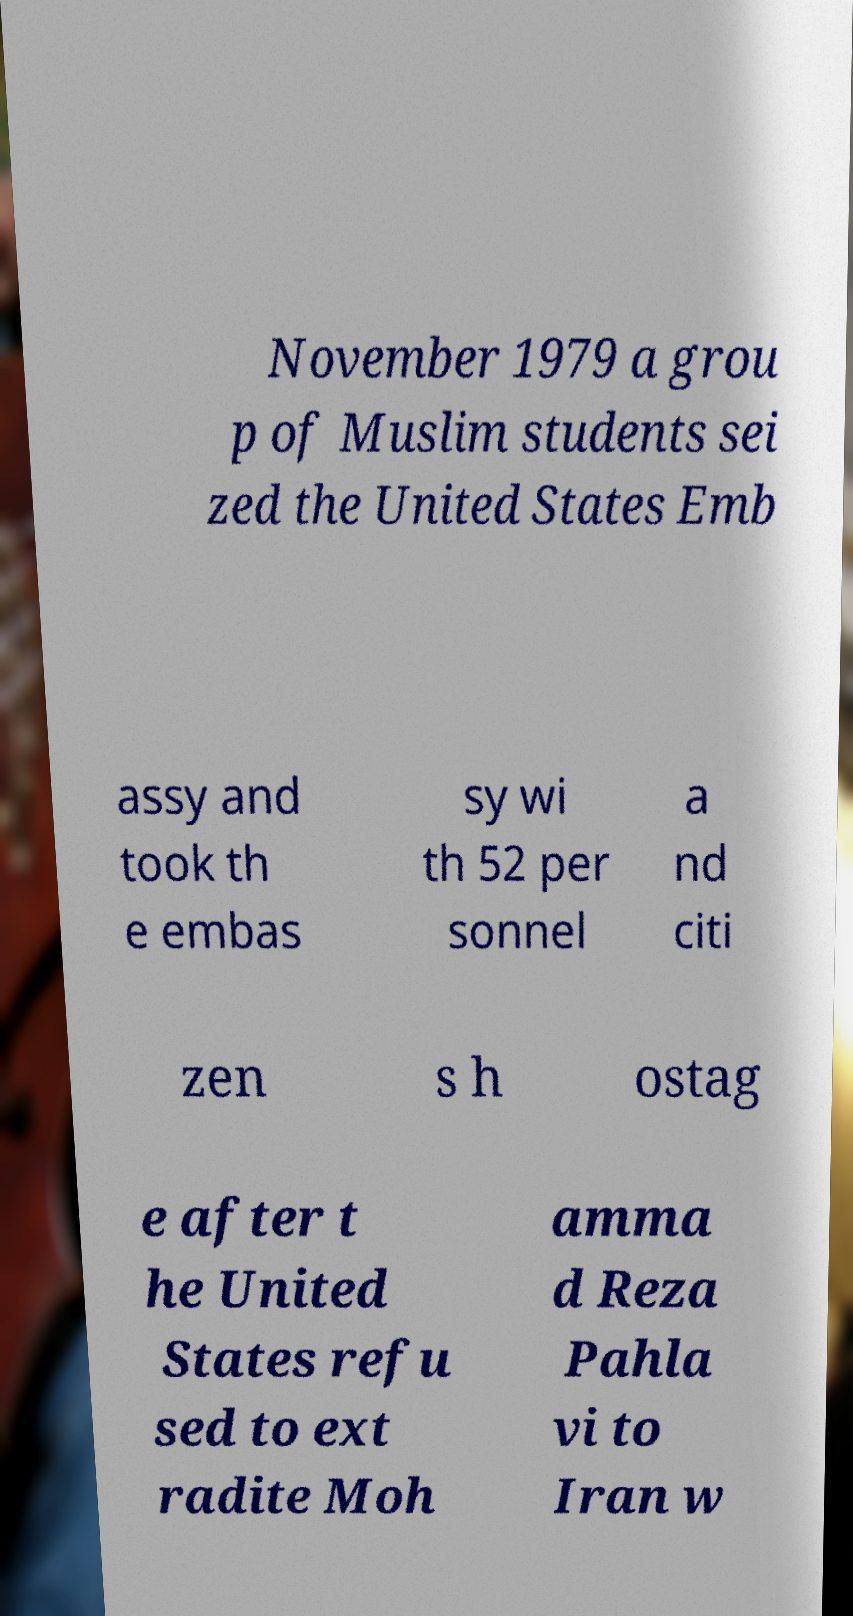Please read and relay the text visible in this image. What does it say? November 1979 a grou p of Muslim students sei zed the United States Emb assy and took th e embas sy wi th 52 per sonnel a nd citi zen s h ostag e after t he United States refu sed to ext radite Moh amma d Reza Pahla vi to Iran w 